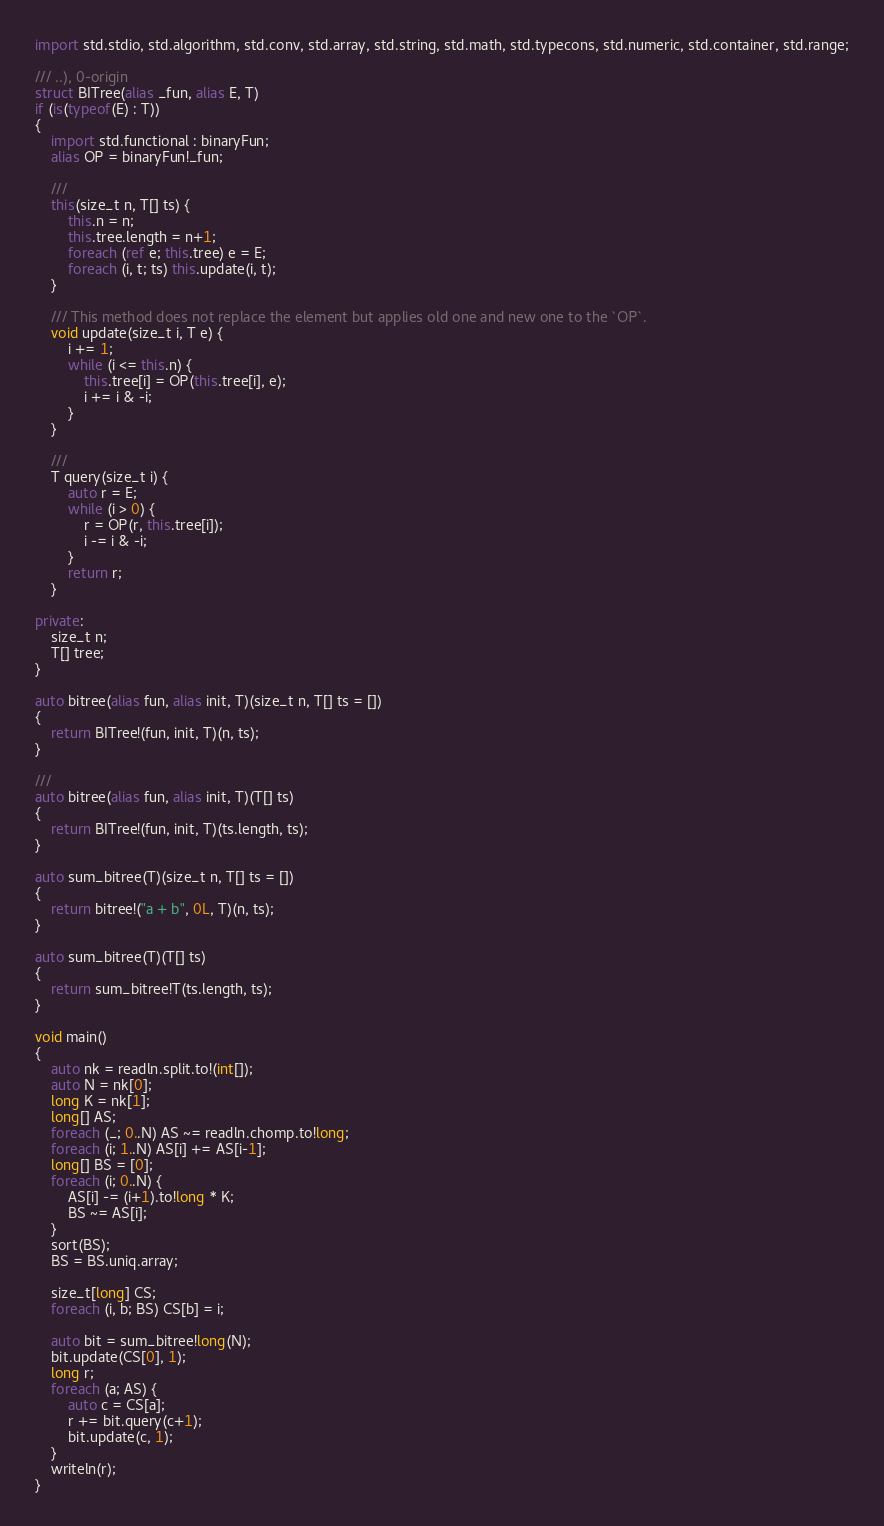Convert code to text. <code><loc_0><loc_0><loc_500><loc_500><_D_>import std.stdio, std.algorithm, std.conv, std.array, std.string, std.math, std.typecons, std.numeric, std.container, std.range;

/// ..), 0-origin
struct BITree(alias _fun, alias E, T)
if (is(typeof(E) : T))
{
    import std.functional : binaryFun;
    alias OP = binaryFun!_fun;

    ///
    this(size_t n, T[] ts) {
        this.n = n;
        this.tree.length = n+1;
        foreach (ref e; this.tree) e = E;
        foreach (i, t; ts) this.update(i, t);
    }

    /// This method does not replace the element but applies old one and new one to the `OP`.
    void update(size_t i, T e) {
        i += 1;
        while (i <= this.n) {
            this.tree[i] = OP(this.tree[i], e);
            i += i & -i;
        }
    }

    ///
    T query(size_t i) {
        auto r = E;
        while (i > 0) {
            r = OP(r, this.tree[i]);
            i -= i & -i;
        }
        return r;
    }

private:
    size_t n;
    T[] tree;
}

auto bitree(alias fun, alias init, T)(size_t n, T[] ts = [])
{
    return BITree!(fun, init, T)(n, ts);
}

///
auto bitree(alias fun, alias init, T)(T[] ts)
{
    return BITree!(fun, init, T)(ts.length, ts);
}

auto sum_bitree(T)(size_t n, T[] ts = [])
{
    return bitree!("a + b", 0L, T)(n, ts);
}

auto sum_bitree(T)(T[] ts)
{
    return sum_bitree!T(ts.length, ts);
}

void main()
{
    auto nk = readln.split.to!(int[]);
    auto N = nk[0];
    long K = nk[1];
    long[] AS;
    foreach (_; 0..N) AS ~= readln.chomp.to!long;
    foreach (i; 1..N) AS[i] += AS[i-1];
    long[] BS = [0];
    foreach (i; 0..N) {
        AS[i] -= (i+1).to!long * K;
        BS ~= AS[i];
    }
    sort(BS);
    BS = BS.uniq.array;

    size_t[long] CS;
    foreach (i, b; BS) CS[b] = i;

    auto bit = sum_bitree!long(N);
    bit.update(CS[0], 1);
    long r;
    foreach (a; AS) {
        auto c = CS[a];
        r += bit.query(c+1);
        bit.update(c, 1);
    }
    writeln(r);
}</code> 